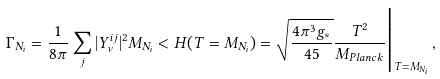<formula> <loc_0><loc_0><loc_500><loc_500>\Gamma _ { N _ { i } } = \frac { 1 } { 8 \pi } \sum _ { j } | Y _ { \nu } ^ { i j } | ^ { 2 } M _ { N _ { i } } < H ( T = M _ { N _ { i } } ) = \sqrt { \frac { 4 \pi ^ { 3 } g _ { \ast } } { 4 5 } } \frac { T ^ { 2 } } { M _ { P l a n c k } } \Big | _ { T = M _ { N _ { i } } } \, ,</formula> 